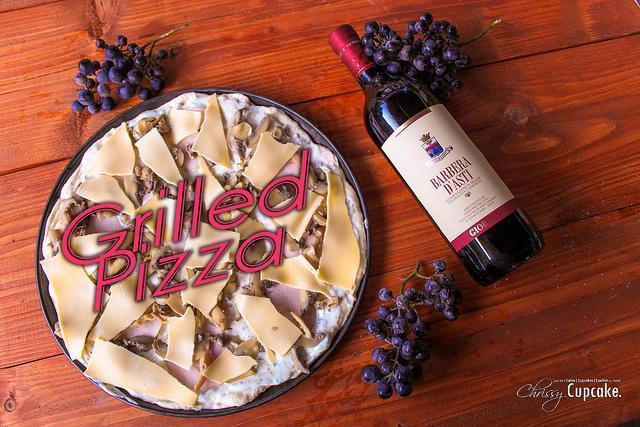How many dogs are in the room?
Give a very brief answer. 0. 